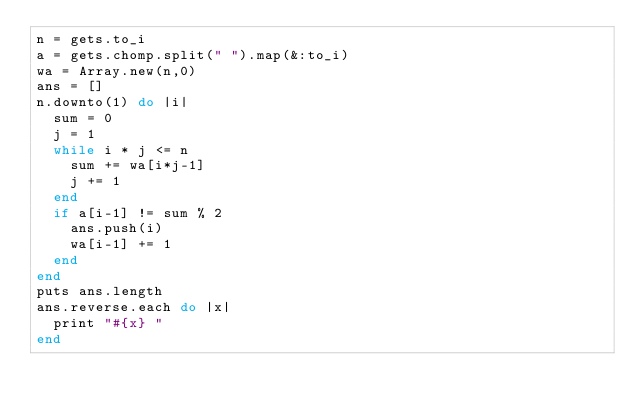Convert code to text. <code><loc_0><loc_0><loc_500><loc_500><_Ruby_>n = gets.to_i
a = gets.chomp.split(" ").map(&:to_i)
wa = Array.new(n,0)
ans = []
n.downto(1) do |i|
  sum = 0
  j = 1
  while i * j <= n
    sum += wa[i*j-1]
    j += 1
  end
  if a[i-1] != sum % 2
    ans.push(i)
    wa[i-1] += 1
  end
end
puts ans.length
ans.reverse.each do |x|
  print "#{x} "
end
</code> 